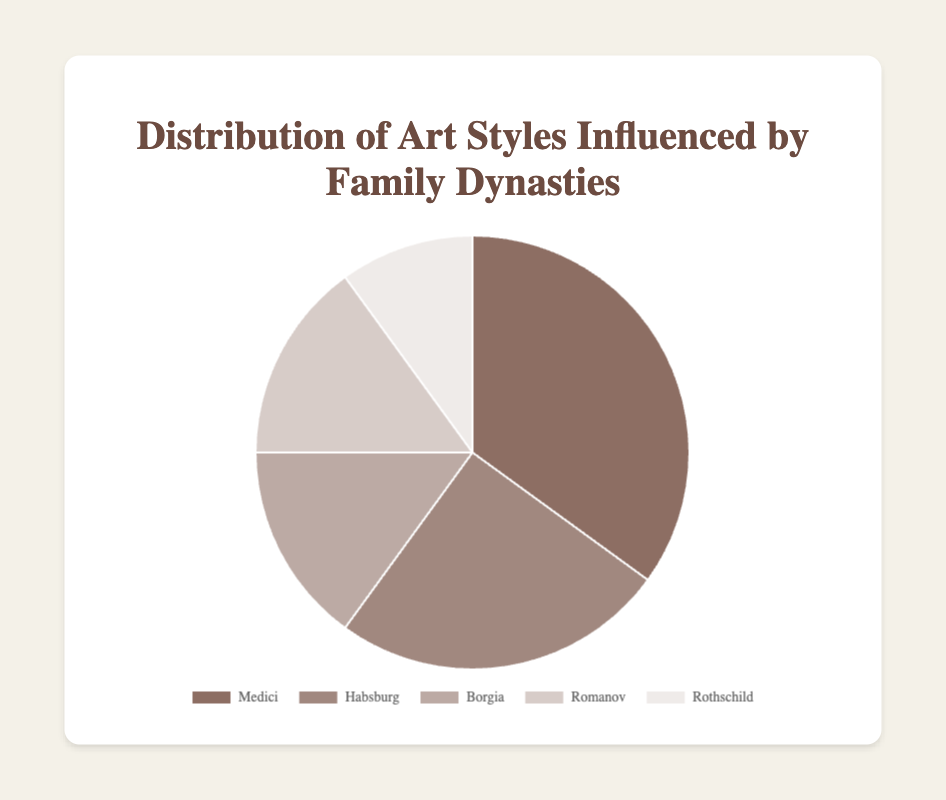What percentage of influence do the Medici and Habsburg dynasties together hold? To find the total influence of the Medici and Habsburg dynasties, sum their individual influence percentages: 35% (Medici) + 25% (Habsburg) = 60%
Answer: 60% Which dynasty has the smallest influence on art styles? Compare the influence percentages of all dynasties and identify the one with the smallest value. The Rothschild dynasty has the smallest influence with 10%.
Answer: Rothschild How much more influence does the Medici dynasty have compared to the Borgia dynasty? Subtract the influence percentage of the Borgia from that of the Medici: 35% (Medici) - 15% (Borgia) = 20%
Answer: 20% Which two dynasties have an equal influence on art styles? Identify the dynasties with matching influence percentages. Both the Borgia and Romanov dynasties have equal influence at 15% each.
Answer: Borgia, Romanov Are any of the influence percentages greater than 30%? Check each percentage to determine if any are greater than 30%. The Medici dynasty's influence is 35%, which is greater than 30%.
Answer: Yes What is the difference between the highest and lowest influence percentages? Subtract the lowest influence percentage (Rothschild at 10%) from the highest (Medici at 35%): 35% - 10% = 25%
Answer: 25% What fraction of the total influence is held by the Romanov and Rothschild dynasties combined? Add the influence percentages of the Romanov and Rothschild dynasties: 15% (Romanov) + 10% (Rothschild) = 25%. Since the total influence across all dynasties is 100%, the fraction is 25/100.
Answer: 1/4 Which dynasty's influence percentage can be inferred from its visual segment being a lighter color compared to others? According to the visual description, the dynasty with the lightest color is likely to have one of the smallest influence percentages. The Rothschild dynasty, with 10%, has the lightest color among the given ones.
Answer: Rothschild How much influence do all the non-European dynasties hold together? Sum the influence percentages of non-European dynasties. Since all listed are European, their combined influence is zero for non-European dynasties.
Answer: 0% 